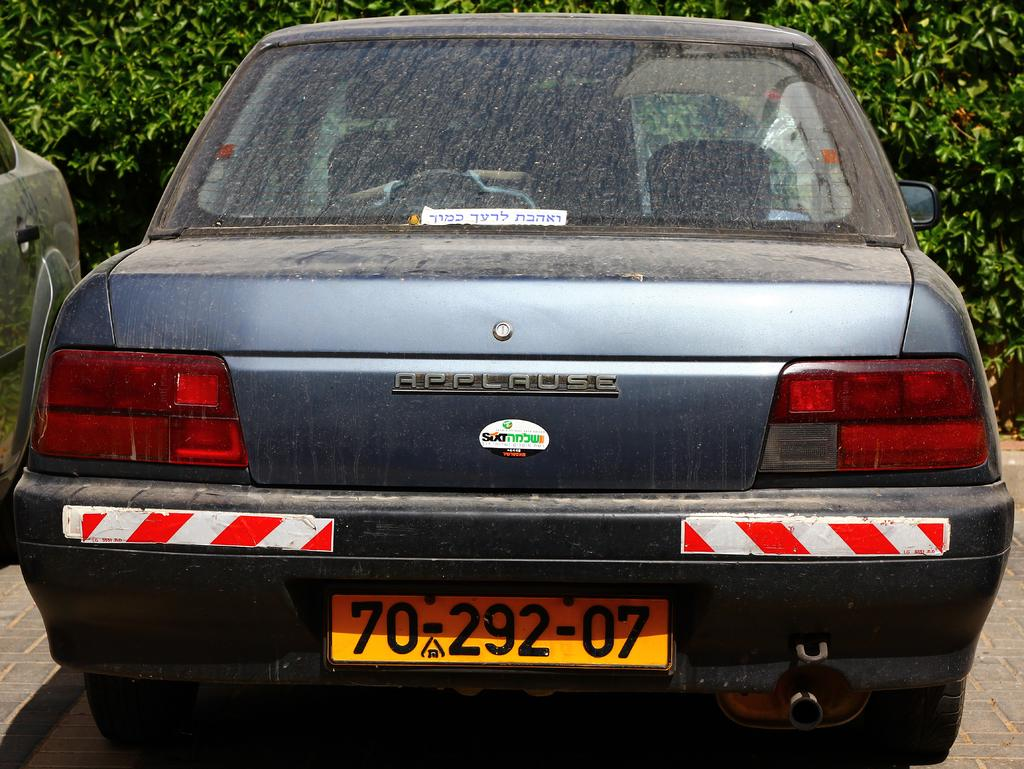<image>
Describe the image concisely. A car called an Applause with license plate 70-292-07 is parked in front of a hedge. 